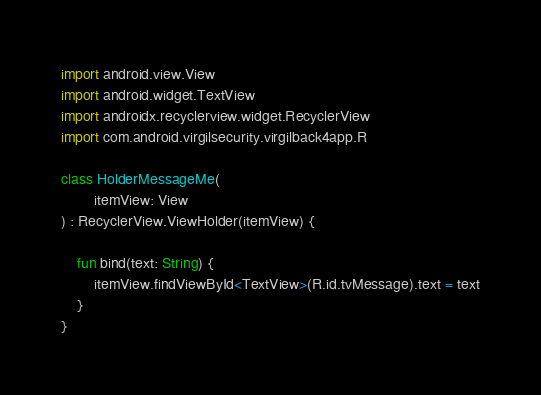Convert code to text. <code><loc_0><loc_0><loc_500><loc_500><_Kotlin_>
import android.view.View
import android.widget.TextView
import androidx.recyclerview.widget.RecyclerView
import com.android.virgilsecurity.virgilback4app.R

class HolderMessageMe(
        itemView: View
) : RecyclerView.ViewHolder(itemView) {

    fun bind(text: String) {
        itemView.findViewById<TextView>(R.id.tvMessage).text = text
    }
}
</code> 